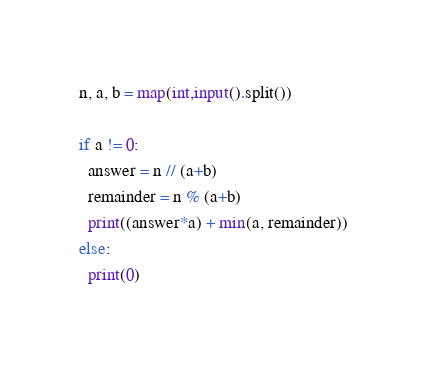Convert code to text. <code><loc_0><loc_0><loc_500><loc_500><_Python_>n, a, b = map(int,input().split())
 
if a != 0:
  answer = n // (a+b)
  remainder = n % (a+b)
  print((answer*a) + min(a, remainder))
else:
  print(0)</code> 